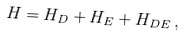<formula> <loc_0><loc_0><loc_500><loc_500>H = H _ { D } + H _ { E } + H _ { D E } \, ,</formula> 